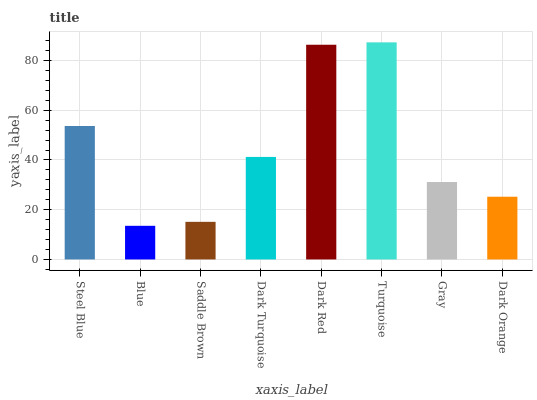Is Blue the minimum?
Answer yes or no. Yes. Is Turquoise the maximum?
Answer yes or no. Yes. Is Saddle Brown the minimum?
Answer yes or no. No. Is Saddle Brown the maximum?
Answer yes or no. No. Is Saddle Brown greater than Blue?
Answer yes or no. Yes. Is Blue less than Saddle Brown?
Answer yes or no. Yes. Is Blue greater than Saddle Brown?
Answer yes or no. No. Is Saddle Brown less than Blue?
Answer yes or no. No. Is Dark Turquoise the high median?
Answer yes or no. Yes. Is Gray the low median?
Answer yes or no. Yes. Is Dark Red the high median?
Answer yes or no. No. Is Saddle Brown the low median?
Answer yes or no. No. 